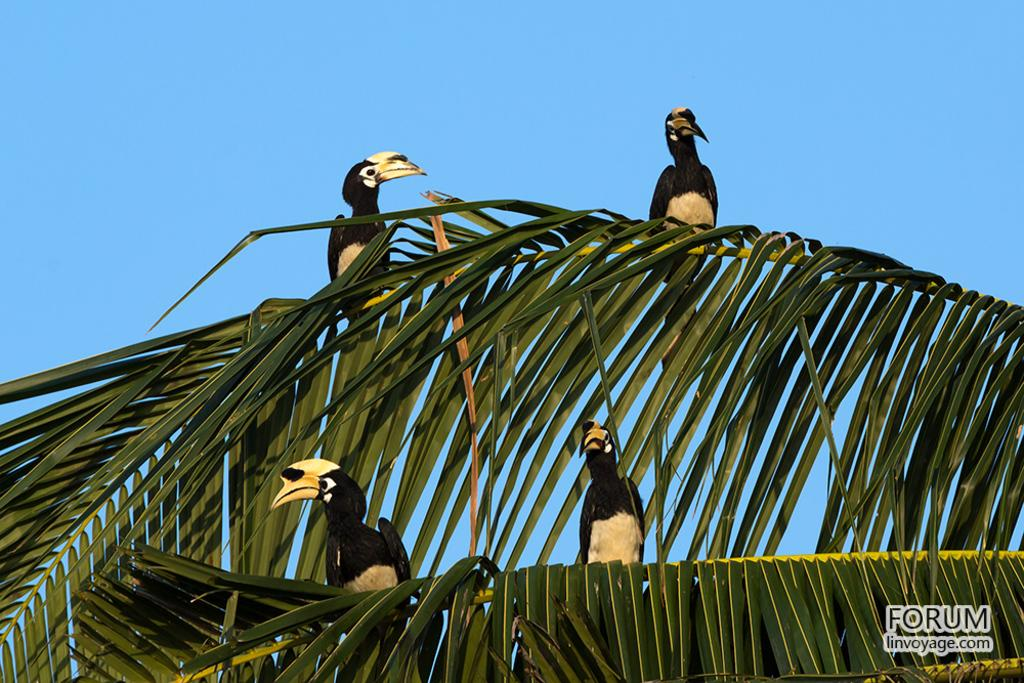What animals are sitting on stems in the image? There are birds sitting on stems in the image. What can be found in the bottom right corner of the image? There is text in the bottom right corner of the image. What is visible in the background of the image? The sky is visible in the background of the image. What type of harmony is being played by the birds in the image? There is no indication of any harmony being played by the birds in the image, as they are simply sitting on stems. 